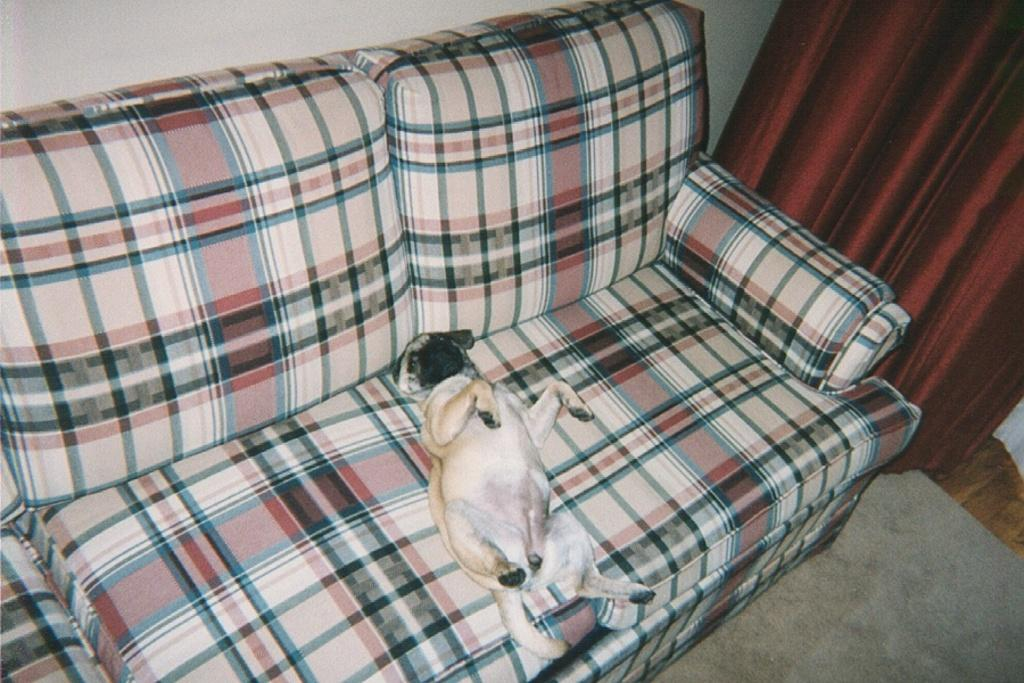What is on the sofa in the image? There is a dog on the sofa in the image. What is on the right side of the image? There is a curtain on the right side of the image. What is on the floor in the image? There is a carpet on the floor in the image. What can be seen in the background of the image? There is a wall visible in the background of the image. What type of cough does the dog have in the image? There is no indication of a cough in the image; the dog is simply sitting on the sofa. 